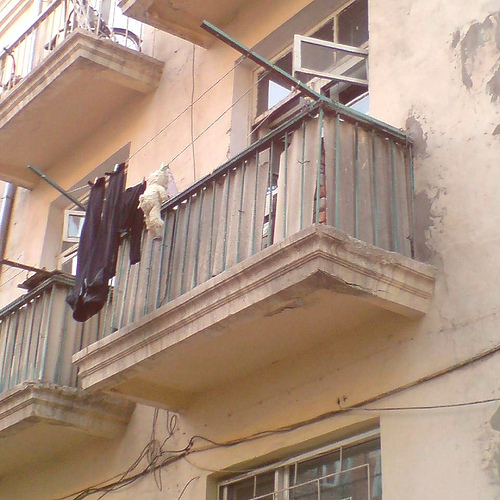<image>
Is there a stuffed animal on the balcony? Yes. Looking at the image, I can see the stuffed animal is positioned on top of the balcony, with the balcony providing support. 